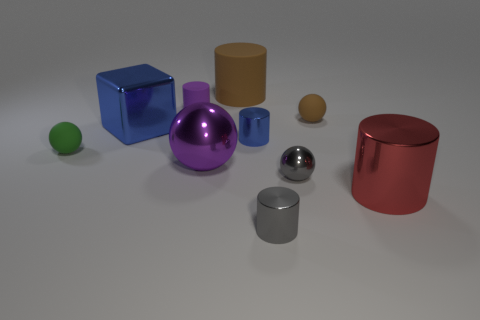The big shiny ball is what color?
Provide a succinct answer. Purple. Are there any other things that have the same shape as the large red metal object?
Make the answer very short. Yes. What is the color of the large shiny object that is the same shape as the green rubber object?
Provide a succinct answer. Purple. Is the green thing the same shape as the large purple thing?
Provide a succinct answer. Yes. What number of cubes are either big red things or big blue objects?
Your answer should be very brief. 1. The tiny sphere that is made of the same material as the large purple sphere is what color?
Your response must be concise. Gray. There is a brown thing that is to the left of the gray metal ball; is it the same size as the tiny blue object?
Make the answer very short. No. Is the small blue thing made of the same material as the big cylinder that is behind the tiny green sphere?
Your response must be concise. No. What color is the small ball that is left of the small gray sphere?
Your response must be concise. Green. Is there a small metallic ball to the right of the big cylinder that is in front of the tiny blue thing?
Make the answer very short. No. 